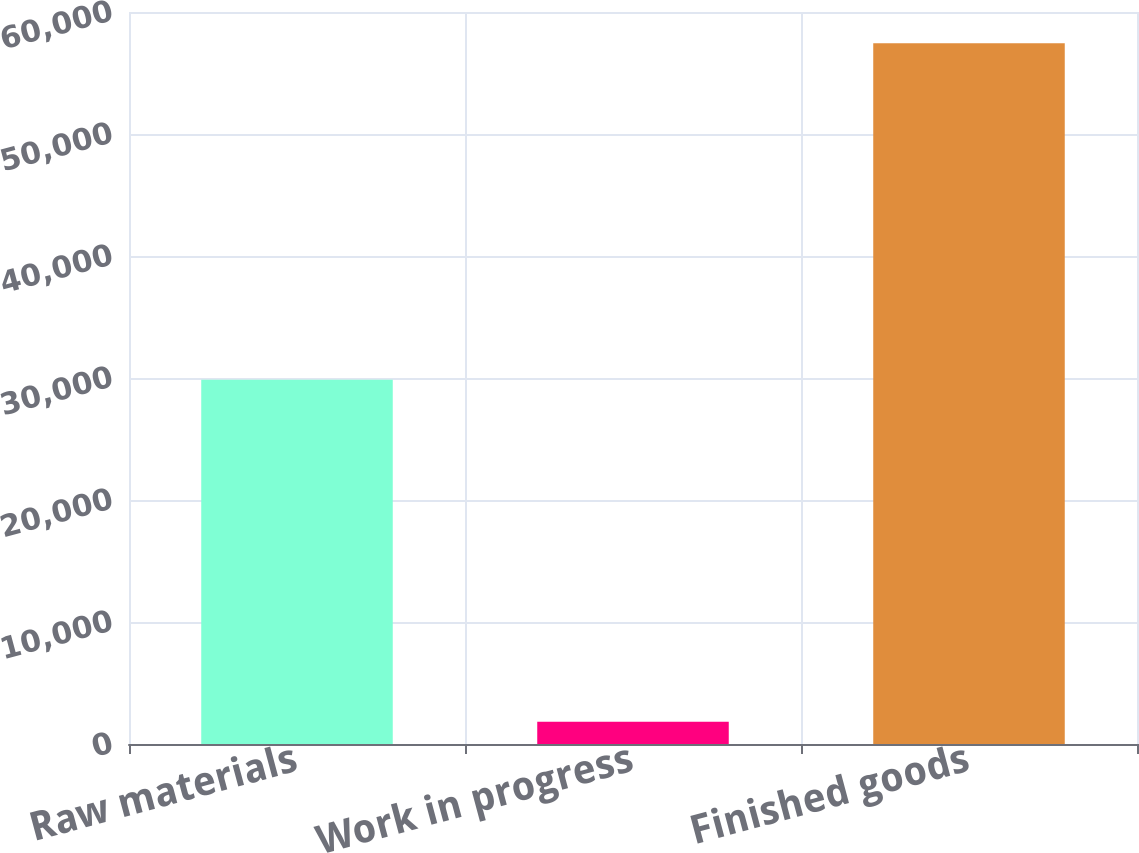<chart> <loc_0><loc_0><loc_500><loc_500><bar_chart><fcel>Raw materials<fcel>Work in progress<fcel>Finished goods<nl><fcel>29857<fcel>1820<fcel>57430<nl></chart> 